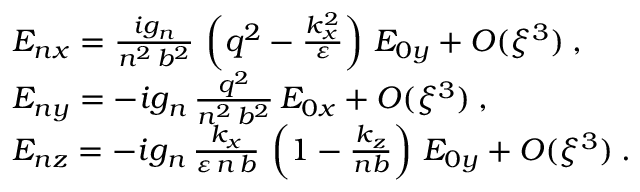Convert formula to latex. <formula><loc_0><loc_0><loc_500><loc_500>\begin{array} { r l } & { E _ { n x } = \frac { i g _ { n } } { n ^ { 2 } \, b ^ { 2 } } \, \left ( q ^ { 2 } - \frac { k _ { x } ^ { 2 } } { \varepsilon } \right ) \, E _ { 0 y } + O ( \xi ^ { 3 } ) \, , } \\ & { E _ { n y } = - i g _ { n } \, \frac { q ^ { 2 } } { n ^ { 2 } \, b ^ { 2 } } \, E _ { 0 x } + O ( \xi ^ { 3 } ) \, , } \\ & { E _ { n z } = - i g _ { n } \, \frac { k _ { x } } { \varepsilon \, n \, b } \, \left ( 1 - \frac { k _ { z } } { n b } \right ) \, E _ { 0 y } + O ( \xi ^ { 3 } ) \, . } \end{array}</formula> 